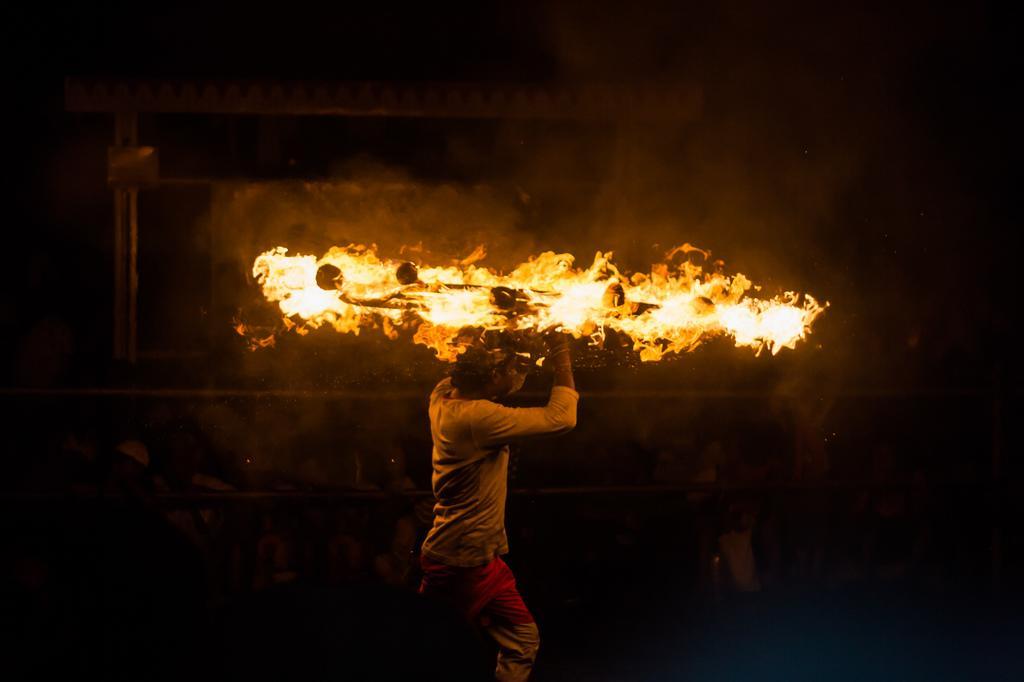Describe this image in one or two sentences. In this image we can see there is a person walking and holding a stand with fire. At the back there is an arch. 